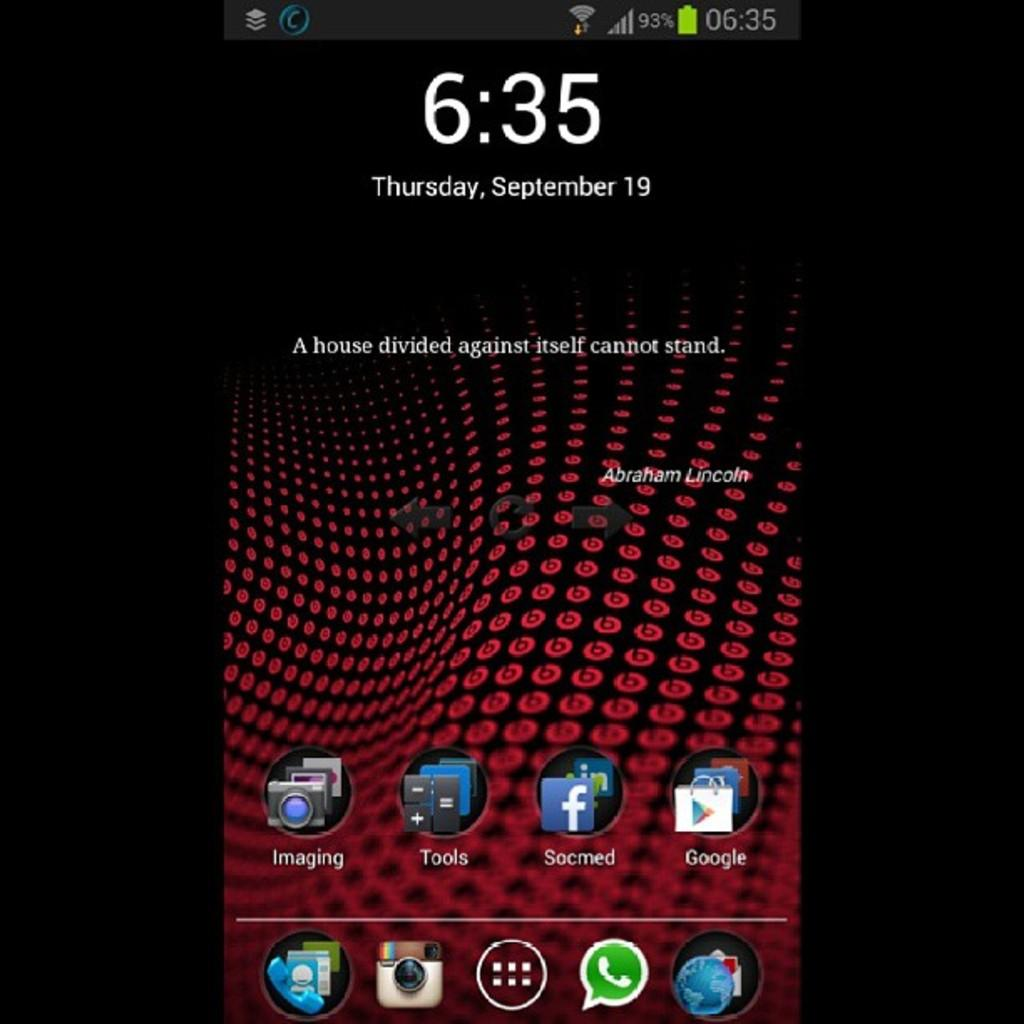<image>
Relay a brief, clear account of the picture shown. The display of a cell phone that was taken on September 19th 